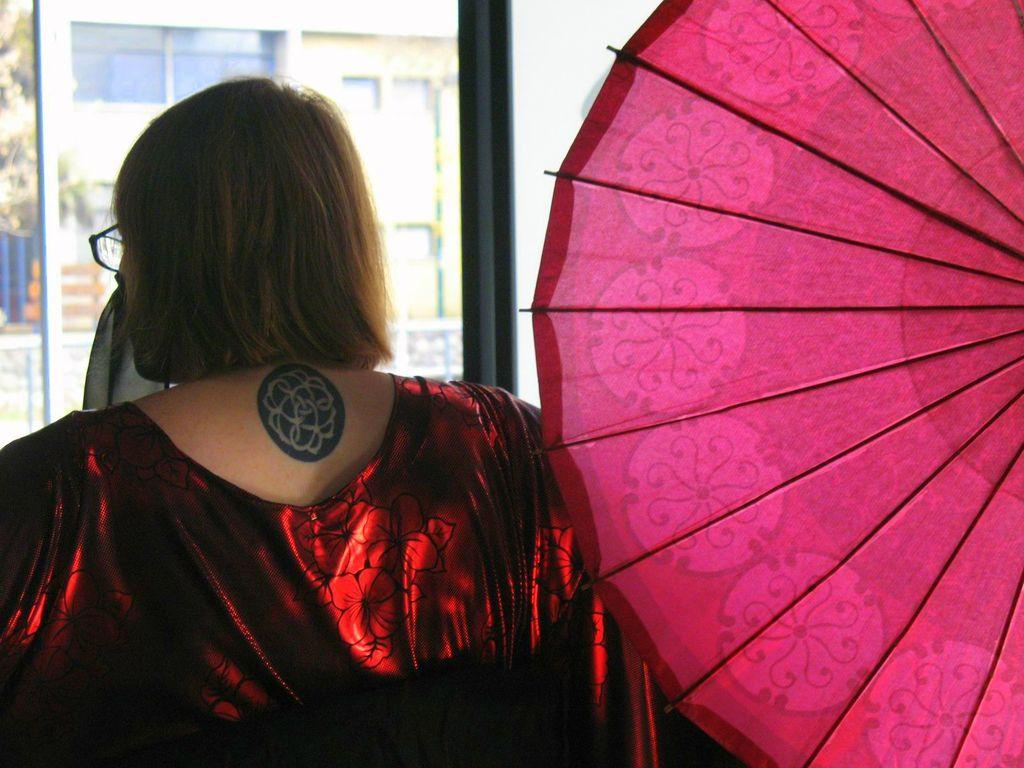What color is the umbrella in the image? The umbrella in the image is pink. Can you describe the person in the image? There is a person in the image, but no specific details about their appearance are provided. What can be seen in the background of the image? There are buildings, a pole, and a tree in the background of the image. How many cows are visible in the image? There are no cows present in the image. What type of pin is the person wearing in the image? There is no mention of a pin or any specific clothing items worn by the person in the image. 